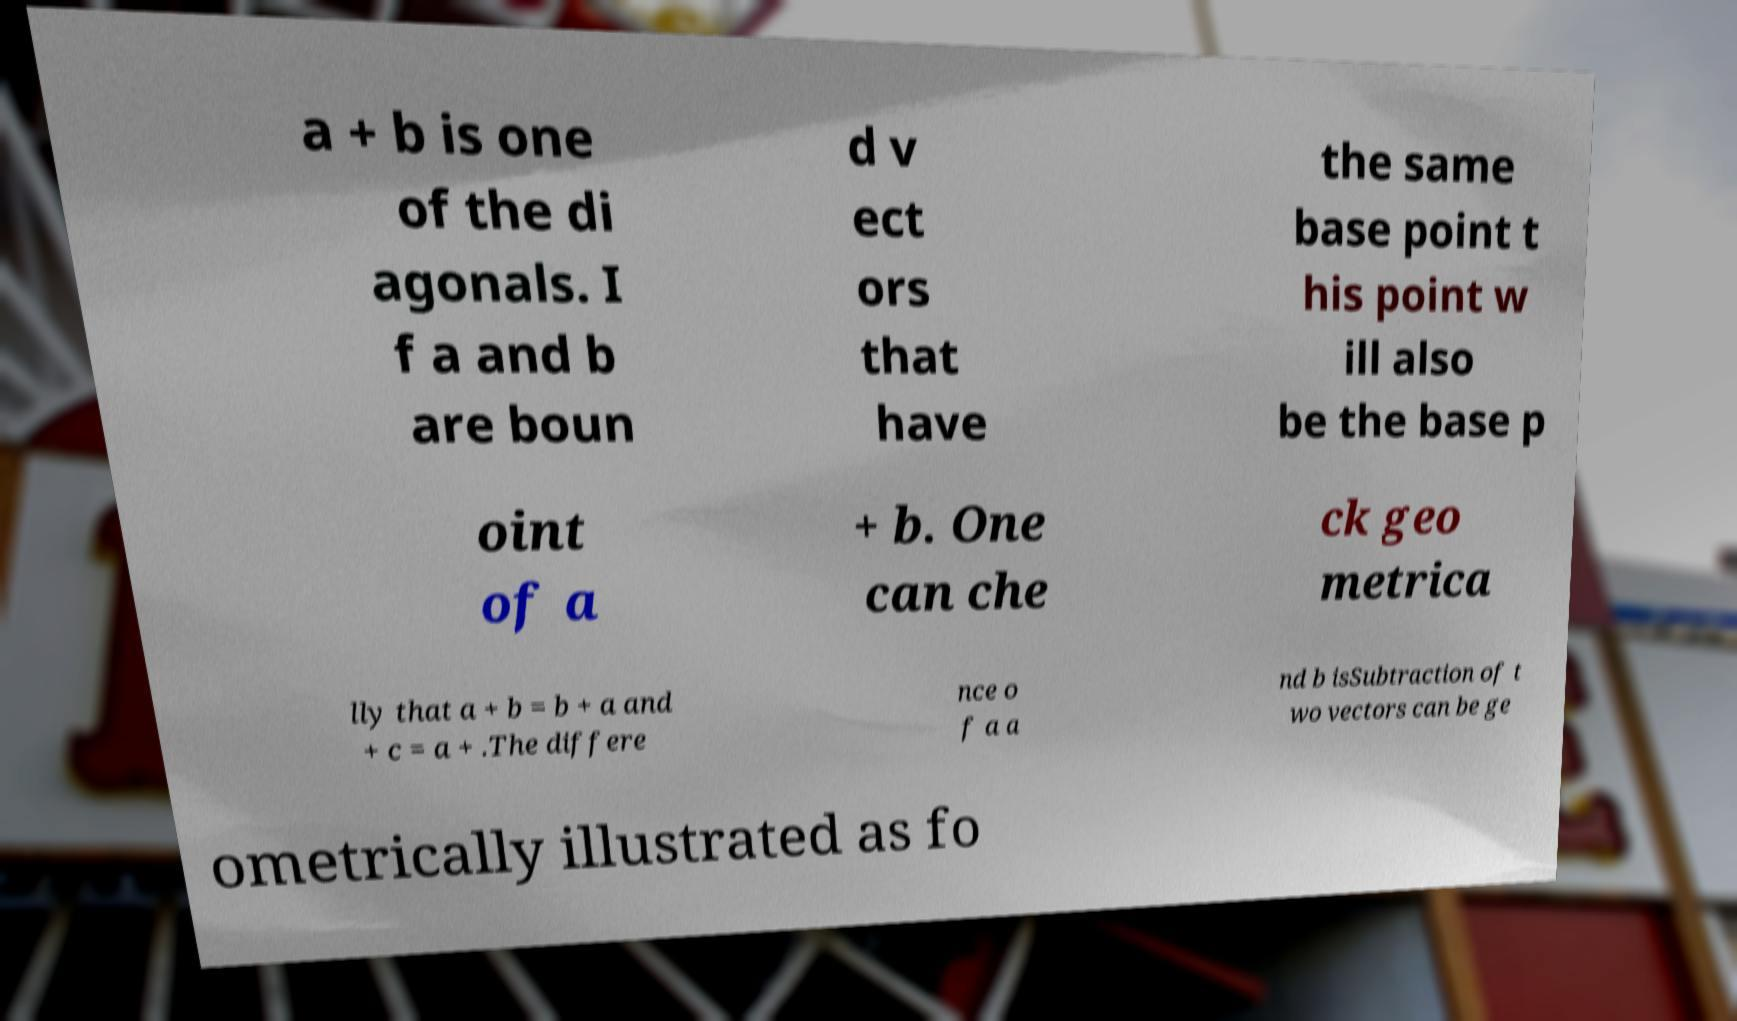I need the written content from this picture converted into text. Can you do that? a + b is one of the di agonals. I f a and b are boun d v ect ors that have the same base point t his point w ill also be the base p oint of a + b. One can che ck geo metrica lly that a + b = b + a and + c = a + .The differe nce o f a a nd b isSubtraction of t wo vectors can be ge ometrically illustrated as fo 